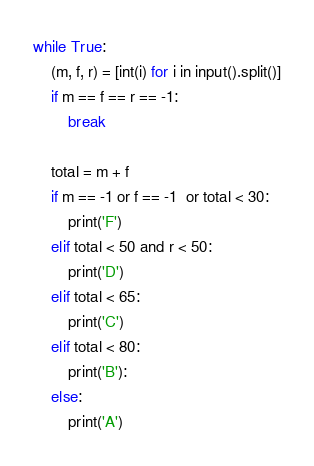<code> <loc_0><loc_0><loc_500><loc_500><_Python_>while True:
    (m, f, r) = [int(i) for i in input().split()]
    if m == f == r == -1:
        break

    total = m + f
    if m == -1 or f == -1  or total < 30:
        print('F')
    elif total < 50 and r < 50:
        print('D')
    elif total < 65:
        print('C')
    elif total < 80:
        print('B'):
    else:
        print('A')</code> 